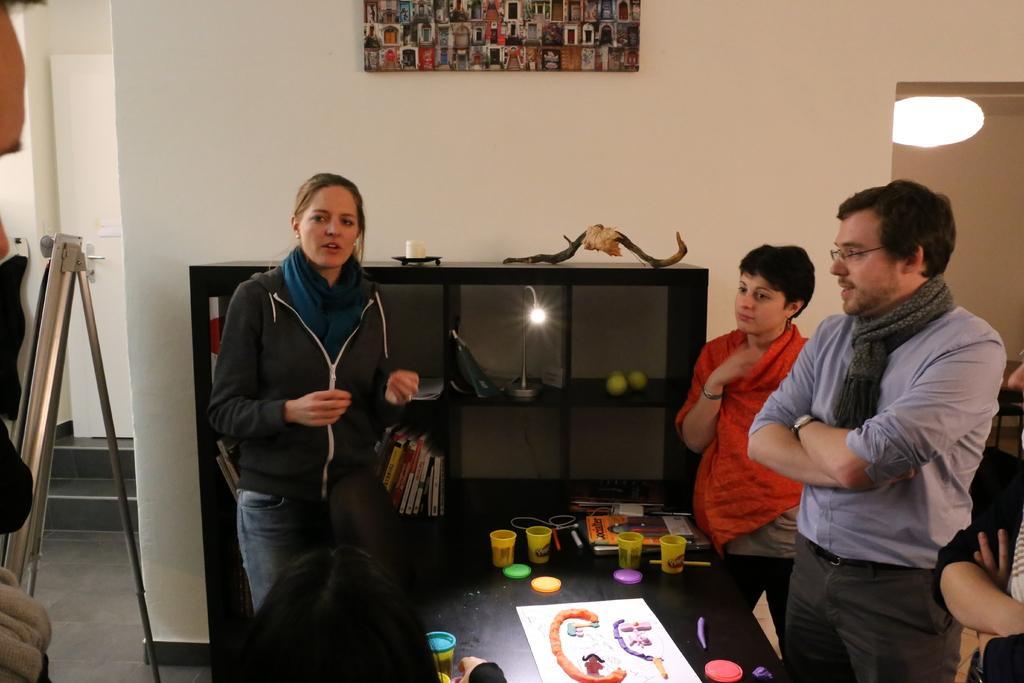Describe this image in one or two sentences. In this image there are 2 woman , man, another person to the right side of the corner standing ,and in table there are paper, toys, glass, rope, pen, books,kids on the table and a chair , there are some books , light, balls placed in a rack and in the back ground there is a frame attached to wall, chandelier, tripod stand and a door. 